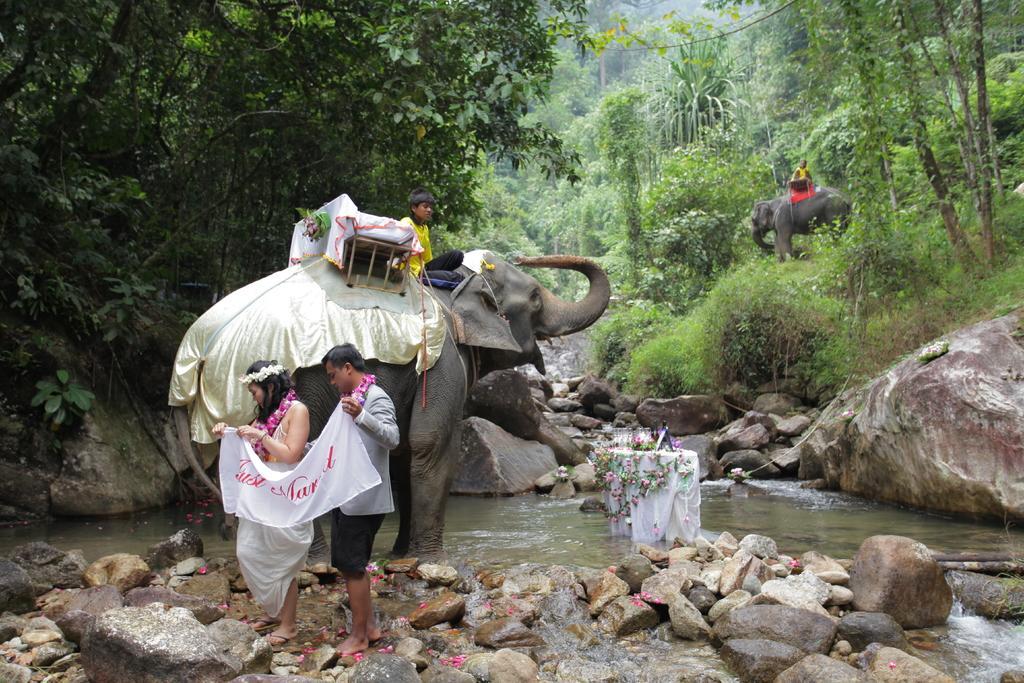Describe this image in one or two sentences. It looks like a vacation spot, there are two elephants, in front of the first elephant there is a couple, on the elephant a person is sitting, there is a lake beside the elephant and the it is a table placed on the lake there are a lot of rocks and hills, in the background there are big trees and also many bushes. 